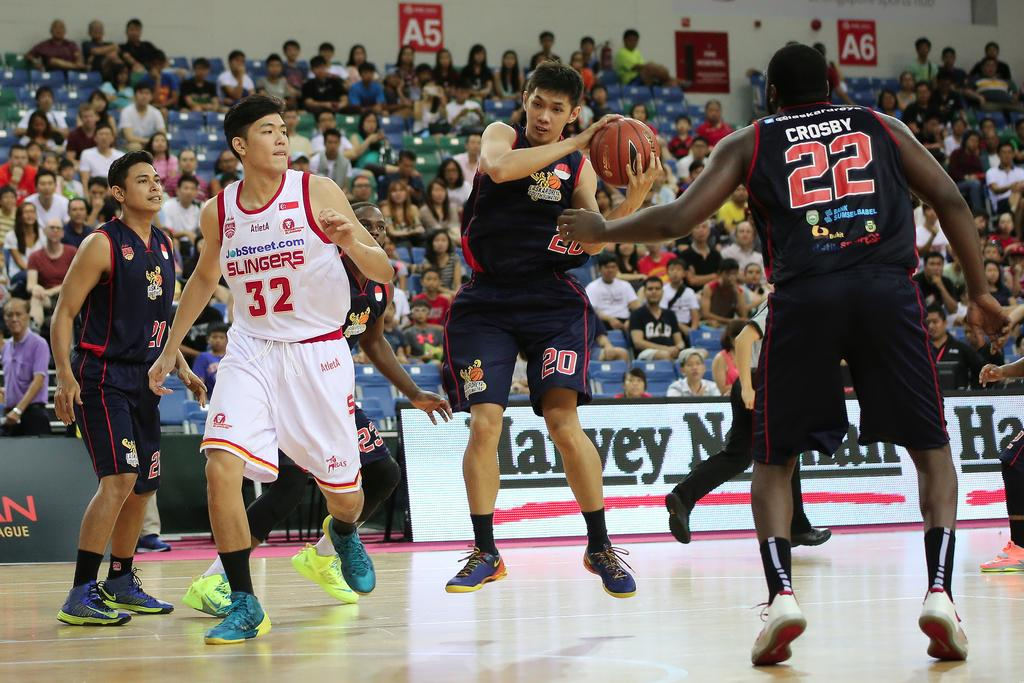<image>
Write a terse but informative summary of the picture. A basketball player has the number 22 on the back of his jersey. 